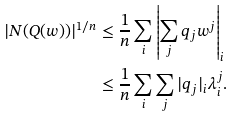Convert formula to latex. <formula><loc_0><loc_0><loc_500><loc_500>| N ( Q ( w ) ) | ^ { 1 / n } & \leq \frac { 1 } { n } \sum _ { i } \left | \sum _ { j } q _ { j } w ^ { j } \right | _ { i } \\ & \leq \frac { 1 } { n } \sum _ { i } \sum _ { j } | q _ { j } | _ { i } \lambda _ { i } ^ { j } .</formula> 